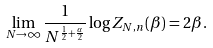<formula> <loc_0><loc_0><loc_500><loc_500>\lim _ { N \rightarrow \infty } \frac { 1 } { N ^ { \frac { 1 } { 2 } + \frac { \alpha } { 2 } } } \log Z _ { N , n } ( \beta ) = 2 \beta .</formula> 